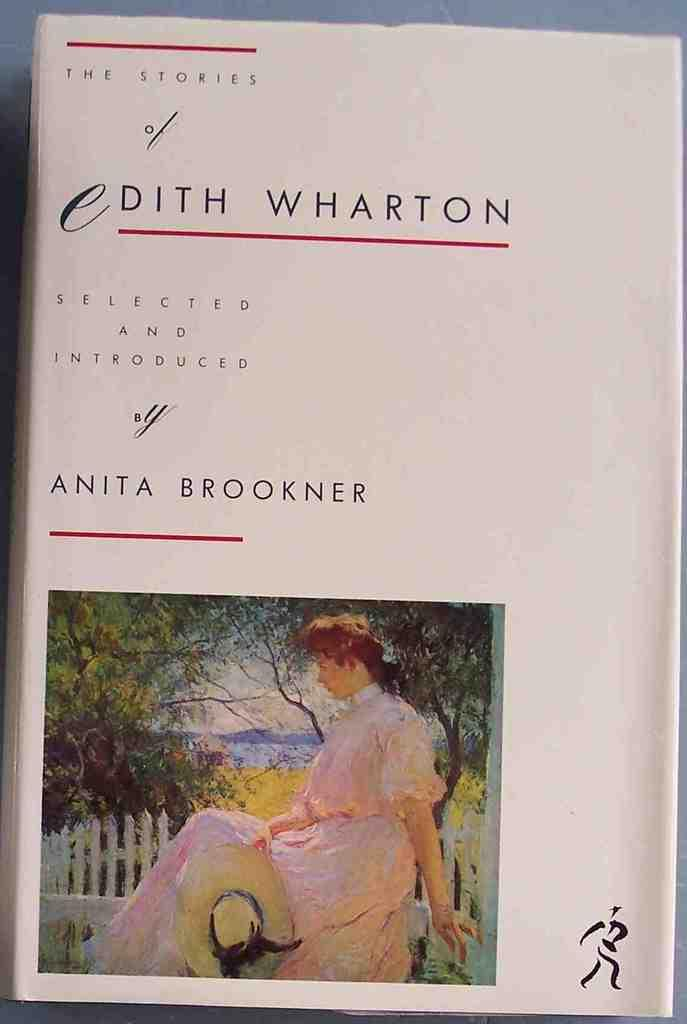<image>
Write a terse but informative summary of the picture. The cover of The Stories of Edith Wharton features an impressionist painting of a woman. 